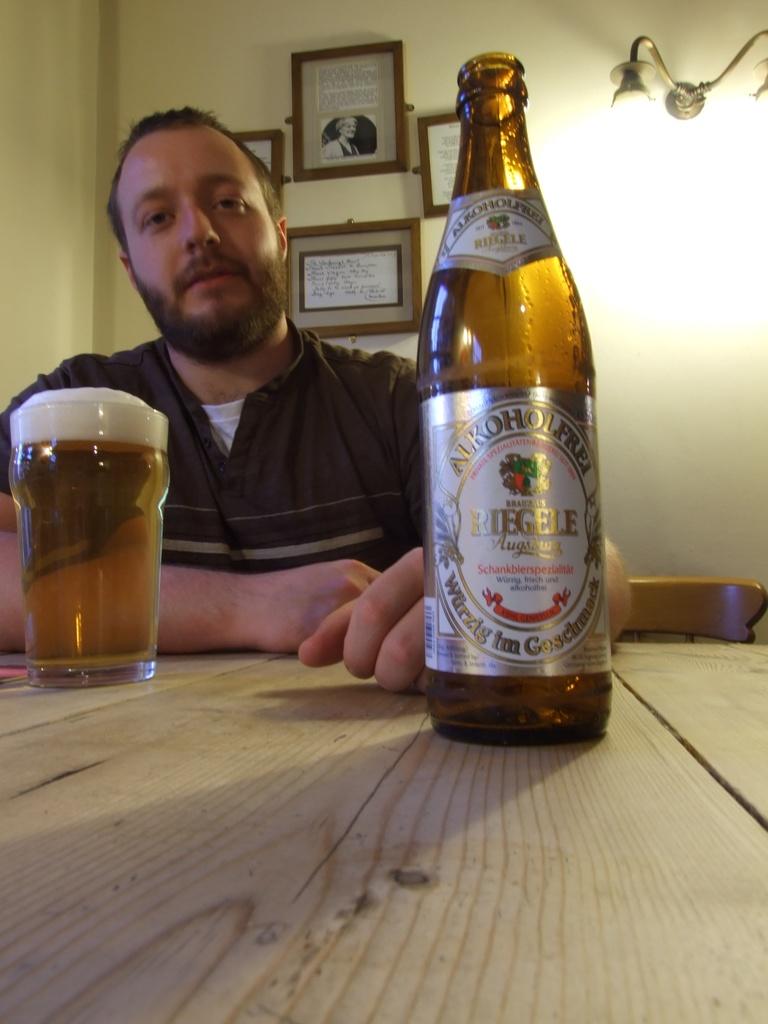What brand of drink is this?
Provide a succinct answer. Riegele. This is bear?
Your answer should be very brief. Yes. 